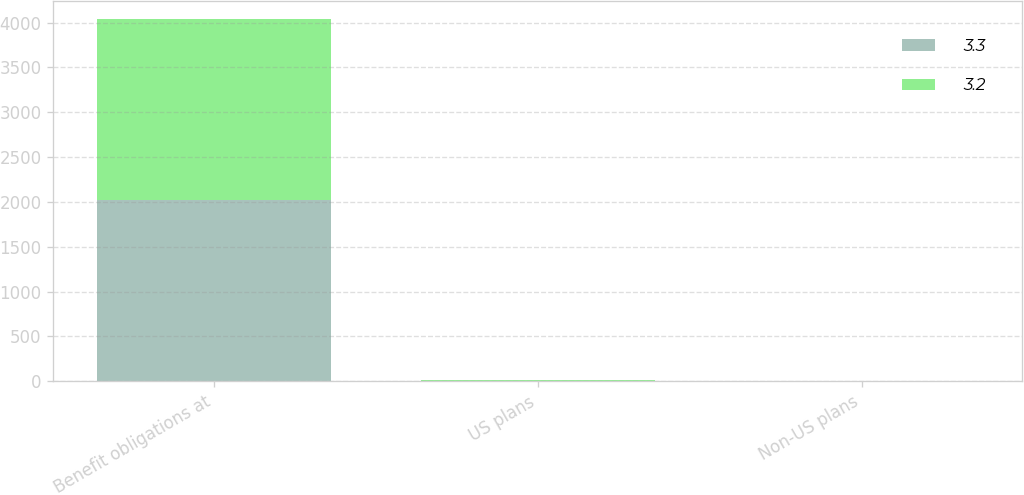Convert chart. <chart><loc_0><loc_0><loc_500><loc_500><stacked_bar_chart><ecel><fcel>Benefit obligations at<fcel>US plans<fcel>Non-US plans<nl><fcel>3.3<fcel>2018<fcel>4.3<fcel>2.8<nl><fcel>3.2<fcel>2017<fcel>3.6<fcel>2.5<nl></chart> 